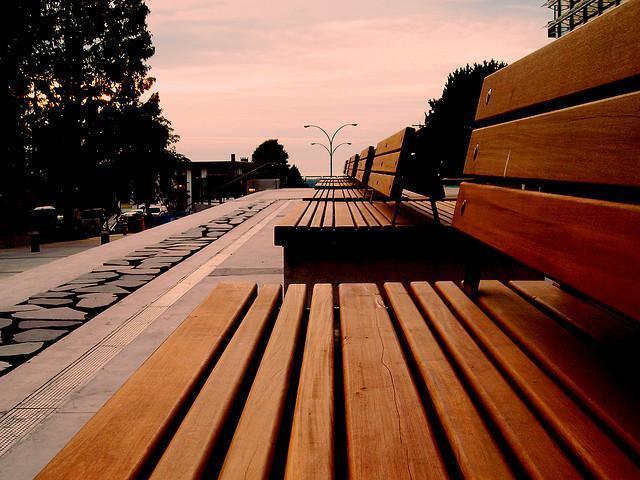How many narrow beams make up one bench?
Give a very brief answer. 6. How many benches are in the photo?
Give a very brief answer. 2. 